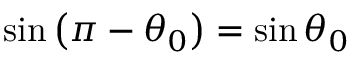Convert formula to latex. <formula><loc_0><loc_0><loc_500><loc_500>\sin \left ( \pi - \theta _ { 0 } \right ) = \sin \theta _ { 0 }</formula> 